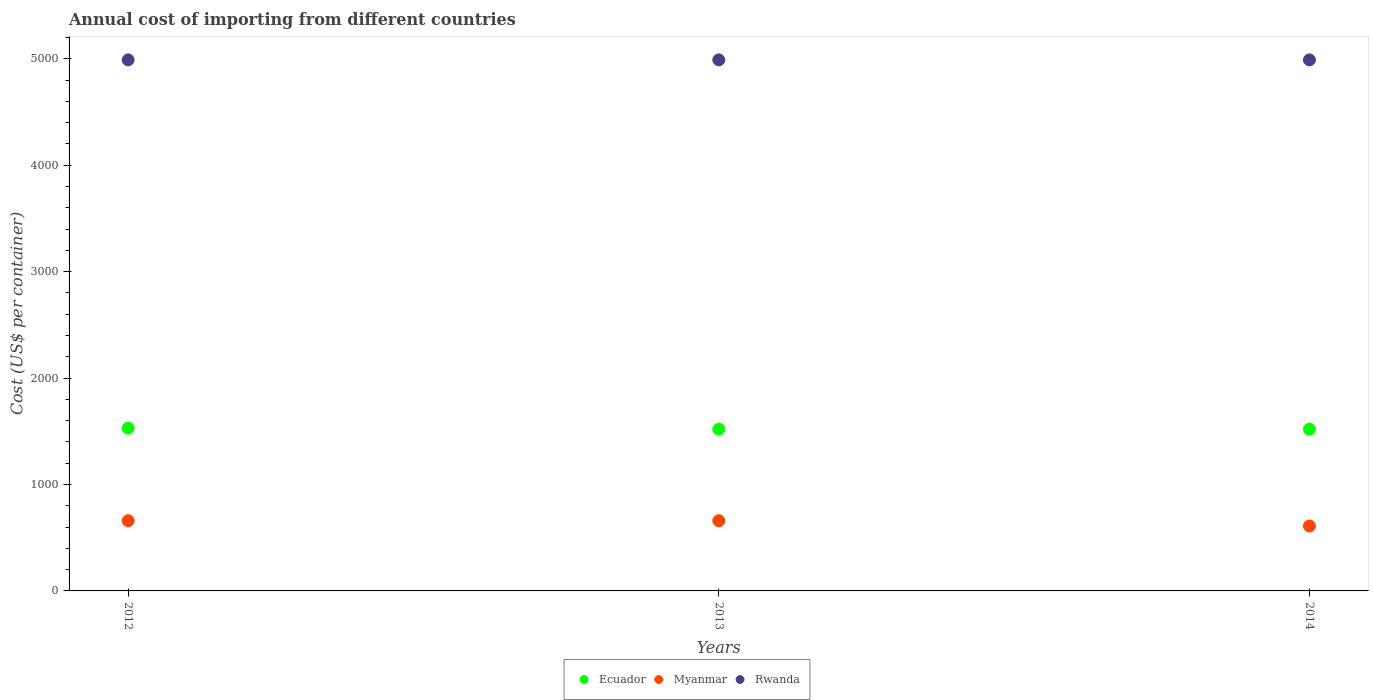How many different coloured dotlines are there?
Provide a short and direct response. 3. Is the number of dotlines equal to the number of legend labels?
Offer a terse response. Yes. What is the total annual cost of importing in Myanmar in 2013?
Your answer should be compact. 660. Across all years, what is the maximum total annual cost of importing in Ecuador?
Ensure brevity in your answer.  1530. Across all years, what is the minimum total annual cost of importing in Myanmar?
Your answer should be very brief. 610. What is the total total annual cost of importing in Rwanda in the graph?
Your answer should be compact. 1.50e+04. What is the difference between the total annual cost of importing in Ecuador in 2012 and that in 2013?
Provide a succinct answer. 10. What is the difference between the total annual cost of importing in Ecuador in 2013 and the total annual cost of importing in Rwanda in 2014?
Provide a short and direct response. -3470. What is the average total annual cost of importing in Ecuador per year?
Give a very brief answer. 1523.33. In the year 2012, what is the difference between the total annual cost of importing in Rwanda and total annual cost of importing in Ecuador?
Offer a very short reply. 3460. In how many years, is the total annual cost of importing in Ecuador greater than 1600 US$?
Provide a succinct answer. 0. What is the ratio of the total annual cost of importing in Ecuador in 2012 to that in 2013?
Your response must be concise. 1.01. Is the difference between the total annual cost of importing in Rwanda in 2013 and 2014 greater than the difference between the total annual cost of importing in Ecuador in 2013 and 2014?
Your answer should be compact. No. What is the difference between the highest and the lowest total annual cost of importing in Ecuador?
Your answer should be compact. 10. Is the sum of the total annual cost of importing in Ecuador in 2013 and 2014 greater than the maximum total annual cost of importing in Rwanda across all years?
Your response must be concise. No. Is it the case that in every year, the sum of the total annual cost of importing in Myanmar and total annual cost of importing in Ecuador  is greater than the total annual cost of importing in Rwanda?
Give a very brief answer. No. Does the total annual cost of importing in Rwanda monotonically increase over the years?
Ensure brevity in your answer.  No. Is the total annual cost of importing in Rwanda strictly greater than the total annual cost of importing in Myanmar over the years?
Provide a succinct answer. Yes. Is the total annual cost of importing in Ecuador strictly less than the total annual cost of importing in Rwanda over the years?
Keep it short and to the point. Yes. How many dotlines are there?
Offer a terse response. 3. How many years are there in the graph?
Give a very brief answer. 3. What is the difference between two consecutive major ticks on the Y-axis?
Provide a short and direct response. 1000. Are the values on the major ticks of Y-axis written in scientific E-notation?
Keep it short and to the point. No. Does the graph contain any zero values?
Your response must be concise. No. Where does the legend appear in the graph?
Give a very brief answer. Bottom center. How are the legend labels stacked?
Offer a terse response. Horizontal. What is the title of the graph?
Your response must be concise. Annual cost of importing from different countries. What is the label or title of the X-axis?
Your answer should be very brief. Years. What is the label or title of the Y-axis?
Your answer should be compact. Cost (US$ per container). What is the Cost (US$ per container) of Ecuador in 2012?
Make the answer very short. 1530. What is the Cost (US$ per container) in Myanmar in 2012?
Provide a short and direct response. 660. What is the Cost (US$ per container) of Rwanda in 2012?
Offer a very short reply. 4990. What is the Cost (US$ per container) of Ecuador in 2013?
Give a very brief answer. 1520. What is the Cost (US$ per container) in Myanmar in 2013?
Ensure brevity in your answer.  660. What is the Cost (US$ per container) in Rwanda in 2013?
Your response must be concise. 4990. What is the Cost (US$ per container) in Ecuador in 2014?
Offer a very short reply. 1520. What is the Cost (US$ per container) of Myanmar in 2014?
Make the answer very short. 610. What is the Cost (US$ per container) of Rwanda in 2014?
Your answer should be very brief. 4990. Across all years, what is the maximum Cost (US$ per container) in Ecuador?
Provide a succinct answer. 1530. Across all years, what is the maximum Cost (US$ per container) of Myanmar?
Your answer should be very brief. 660. Across all years, what is the maximum Cost (US$ per container) of Rwanda?
Your answer should be very brief. 4990. Across all years, what is the minimum Cost (US$ per container) of Ecuador?
Your answer should be very brief. 1520. Across all years, what is the minimum Cost (US$ per container) in Myanmar?
Give a very brief answer. 610. Across all years, what is the minimum Cost (US$ per container) of Rwanda?
Your answer should be very brief. 4990. What is the total Cost (US$ per container) of Ecuador in the graph?
Make the answer very short. 4570. What is the total Cost (US$ per container) in Myanmar in the graph?
Offer a very short reply. 1930. What is the total Cost (US$ per container) in Rwanda in the graph?
Ensure brevity in your answer.  1.50e+04. What is the difference between the Cost (US$ per container) in Ecuador in 2012 and that in 2013?
Offer a terse response. 10. What is the difference between the Cost (US$ per container) in Rwanda in 2012 and that in 2014?
Provide a short and direct response. 0. What is the difference between the Cost (US$ per container) of Ecuador in 2013 and that in 2014?
Keep it short and to the point. 0. What is the difference between the Cost (US$ per container) in Myanmar in 2013 and that in 2014?
Provide a succinct answer. 50. What is the difference between the Cost (US$ per container) in Rwanda in 2013 and that in 2014?
Ensure brevity in your answer.  0. What is the difference between the Cost (US$ per container) of Ecuador in 2012 and the Cost (US$ per container) of Myanmar in 2013?
Keep it short and to the point. 870. What is the difference between the Cost (US$ per container) of Ecuador in 2012 and the Cost (US$ per container) of Rwanda in 2013?
Make the answer very short. -3460. What is the difference between the Cost (US$ per container) in Myanmar in 2012 and the Cost (US$ per container) in Rwanda in 2013?
Your answer should be compact. -4330. What is the difference between the Cost (US$ per container) in Ecuador in 2012 and the Cost (US$ per container) in Myanmar in 2014?
Provide a succinct answer. 920. What is the difference between the Cost (US$ per container) of Ecuador in 2012 and the Cost (US$ per container) of Rwanda in 2014?
Make the answer very short. -3460. What is the difference between the Cost (US$ per container) of Myanmar in 2012 and the Cost (US$ per container) of Rwanda in 2014?
Ensure brevity in your answer.  -4330. What is the difference between the Cost (US$ per container) in Ecuador in 2013 and the Cost (US$ per container) in Myanmar in 2014?
Make the answer very short. 910. What is the difference between the Cost (US$ per container) in Ecuador in 2013 and the Cost (US$ per container) in Rwanda in 2014?
Your answer should be very brief. -3470. What is the difference between the Cost (US$ per container) of Myanmar in 2013 and the Cost (US$ per container) of Rwanda in 2014?
Ensure brevity in your answer.  -4330. What is the average Cost (US$ per container) of Ecuador per year?
Your answer should be very brief. 1523.33. What is the average Cost (US$ per container) of Myanmar per year?
Offer a terse response. 643.33. What is the average Cost (US$ per container) of Rwanda per year?
Offer a terse response. 4990. In the year 2012, what is the difference between the Cost (US$ per container) in Ecuador and Cost (US$ per container) in Myanmar?
Provide a succinct answer. 870. In the year 2012, what is the difference between the Cost (US$ per container) of Ecuador and Cost (US$ per container) of Rwanda?
Keep it short and to the point. -3460. In the year 2012, what is the difference between the Cost (US$ per container) of Myanmar and Cost (US$ per container) of Rwanda?
Offer a very short reply. -4330. In the year 2013, what is the difference between the Cost (US$ per container) in Ecuador and Cost (US$ per container) in Myanmar?
Offer a terse response. 860. In the year 2013, what is the difference between the Cost (US$ per container) in Ecuador and Cost (US$ per container) in Rwanda?
Offer a very short reply. -3470. In the year 2013, what is the difference between the Cost (US$ per container) in Myanmar and Cost (US$ per container) in Rwanda?
Make the answer very short. -4330. In the year 2014, what is the difference between the Cost (US$ per container) in Ecuador and Cost (US$ per container) in Myanmar?
Your answer should be very brief. 910. In the year 2014, what is the difference between the Cost (US$ per container) of Ecuador and Cost (US$ per container) of Rwanda?
Make the answer very short. -3470. In the year 2014, what is the difference between the Cost (US$ per container) of Myanmar and Cost (US$ per container) of Rwanda?
Offer a very short reply. -4380. What is the ratio of the Cost (US$ per container) in Ecuador in 2012 to that in 2013?
Your answer should be very brief. 1.01. What is the ratio of the Cost (US$ per container) of Myanmar in 2012 to that in 2013?
Your answer should be very brief. 1. What is the ratio of the Cost (US$ per container) of Rwanda in 2012 to that in 2013?
Your response must be concise. 1. What is the ratio of the Cost (US$ per container) of Ecuador in 2012 to that in 2014?
Keep it short and to the point. 1.01. What is the ratio of the Cost (US$ per container) in Myanmar in 2012 to that in 2014?
Provide a short and direct response. 1.08. What is the ratio of the Cost (US$ per container) in Rwanda in 2012 to that in 2014?
Offer a very short reply. 1. What is the ratio of the Cost (US$ per container) in Myanmar in 2013 to that in 2014?
Keep it short and to the point. 1.08. What is the ratio of the Cost (US$ per container) in Rwanda in 2013 to that in 2014?
Offer a terse response. 1. What is the difference between the highest and the second highest Cost (US$ per container) of Ecuador?
Make the answer very short. 10. What is the difference between the highest and the second highest Cost (US$ per container) in Myanmar?
Ensure brevity in your answer.  0. What is the difference between the highest and the second highest Cost (US$ per container) in Rwanda?
Your answer should be compact. 0. What is the difference between the highest and the lowest Cost (US$ per container) in Ecuador?
Your response must be concise. 10. What is the difference between the highest and the lowest Cost (US$ per container) in Myanmar?
Give a very brief answer. 50. What is the difference between the highest and the lowest Cost (US$ per container) of Rwanda?
Provide a short and direct response. 0. 